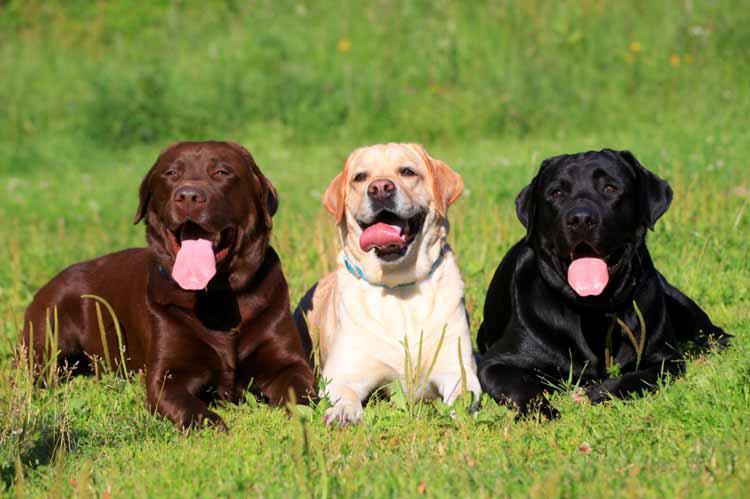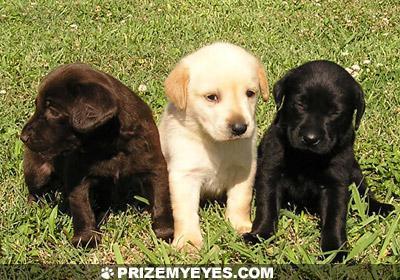The first image is the image on the left, the second image is the image on the right. Examine the images to the left and right. Is the description "There are three dogs sitting on the grass, one black, one brown and one golden." accurate? Answer yes or no. Yes. 